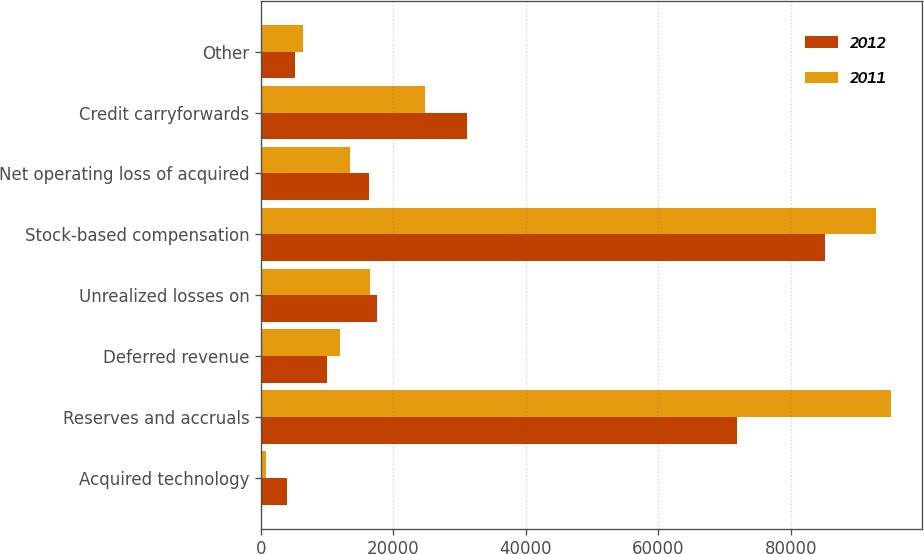Convert chart. <chart><loc_0><loc_0><loc_500><loc_500><stacked_bar_chart><ecel><fcel>Acquired technology<fcel>Reserves and accruals<fcel>Deferred revenue<fcel>Unrealized losses on<fcel>Stock-based compensation<fcel>Net operating loss of acquired<fcel>Credit carryforwards<fcel>Other<nl><fcel>2012<fcel>3890<fcel>71888<fcel>9941<fcel>17482<fcel>85179<fcel>16257<fcel>31172<fcel>5165<nl><fcel>2011<fcel>794<fcel>95077<fcel>11999<fcel>16483<fcel>92817<fcel>13481<fcel>24771<fcel>6298<nl></chart> 